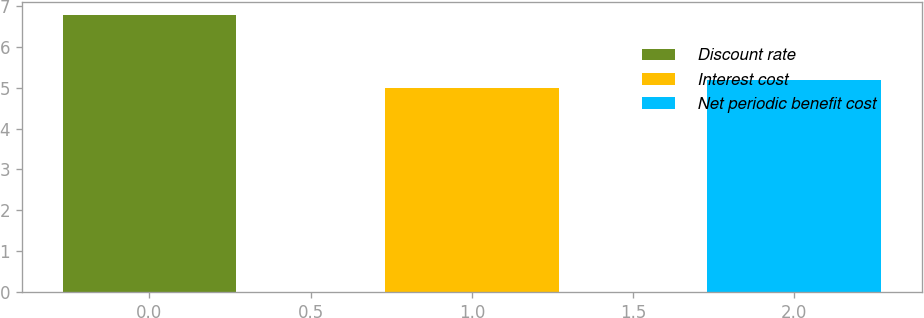Convert chart. <chart><loc_0><loc_0><loc_500><loc_500><bar_chart><fcel>Discount rate<fcel>Interest cost<fcel>Net periodic benefit cost<nl><fcel>6.77<fcel>5<fcel>5.18<nl></chart> 